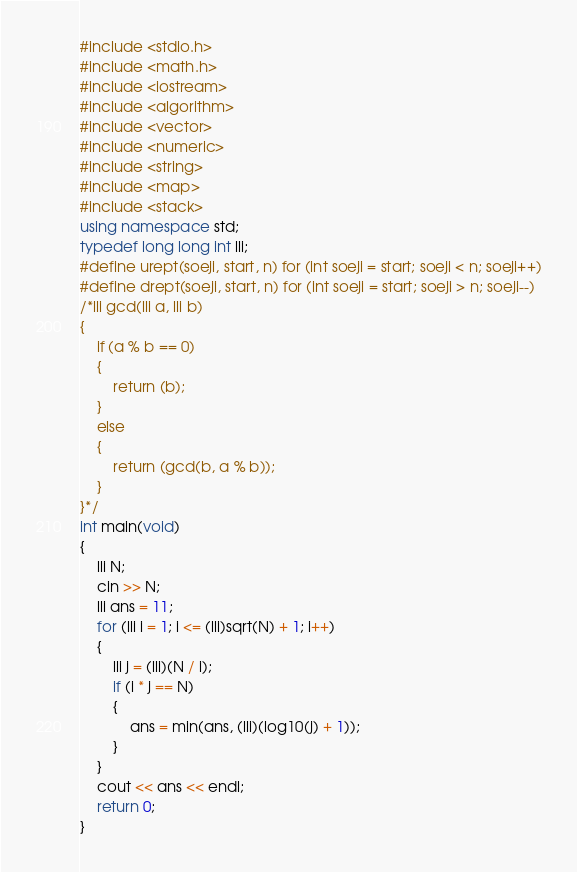Convert code to text. <code><loc_0><loc_0><loc_500><loc_500><_C++_>#include <stdio.h>
#include <math.h>
#include <iostream>
#include <algorithm>
#include <vector>
#include <numeric>
#include <string>
#include <map>
#include <stack>
using namespace std;
typedef long long int lli;
#define urept(soeji, start, n) for (int soeji = start; soeji < n; soeji++)
#define drept(soeji, start, n) for (int soeji = start; soeji > n; soeji--)
/*lli gcd(lli a, lli b)
{
    if (a % b == 0)
    {
        return (b);
    }
    else
    {
        return (gcd(b, a % b));
    }
}*/
int main(void)
{
    lli N;
    cin >> N;
    lli ans = 11;
    for (lli i = 1; i <= (lli)sqrt(N) + 1; i++)
    {
        lli j = (lli)(N / i);
        if (i * j == N)
        {
            ans = min(ans, (lli)(log10(j) + 1));
        }
    }
    cout << ans << endl;
    return 0;
}
</code> 